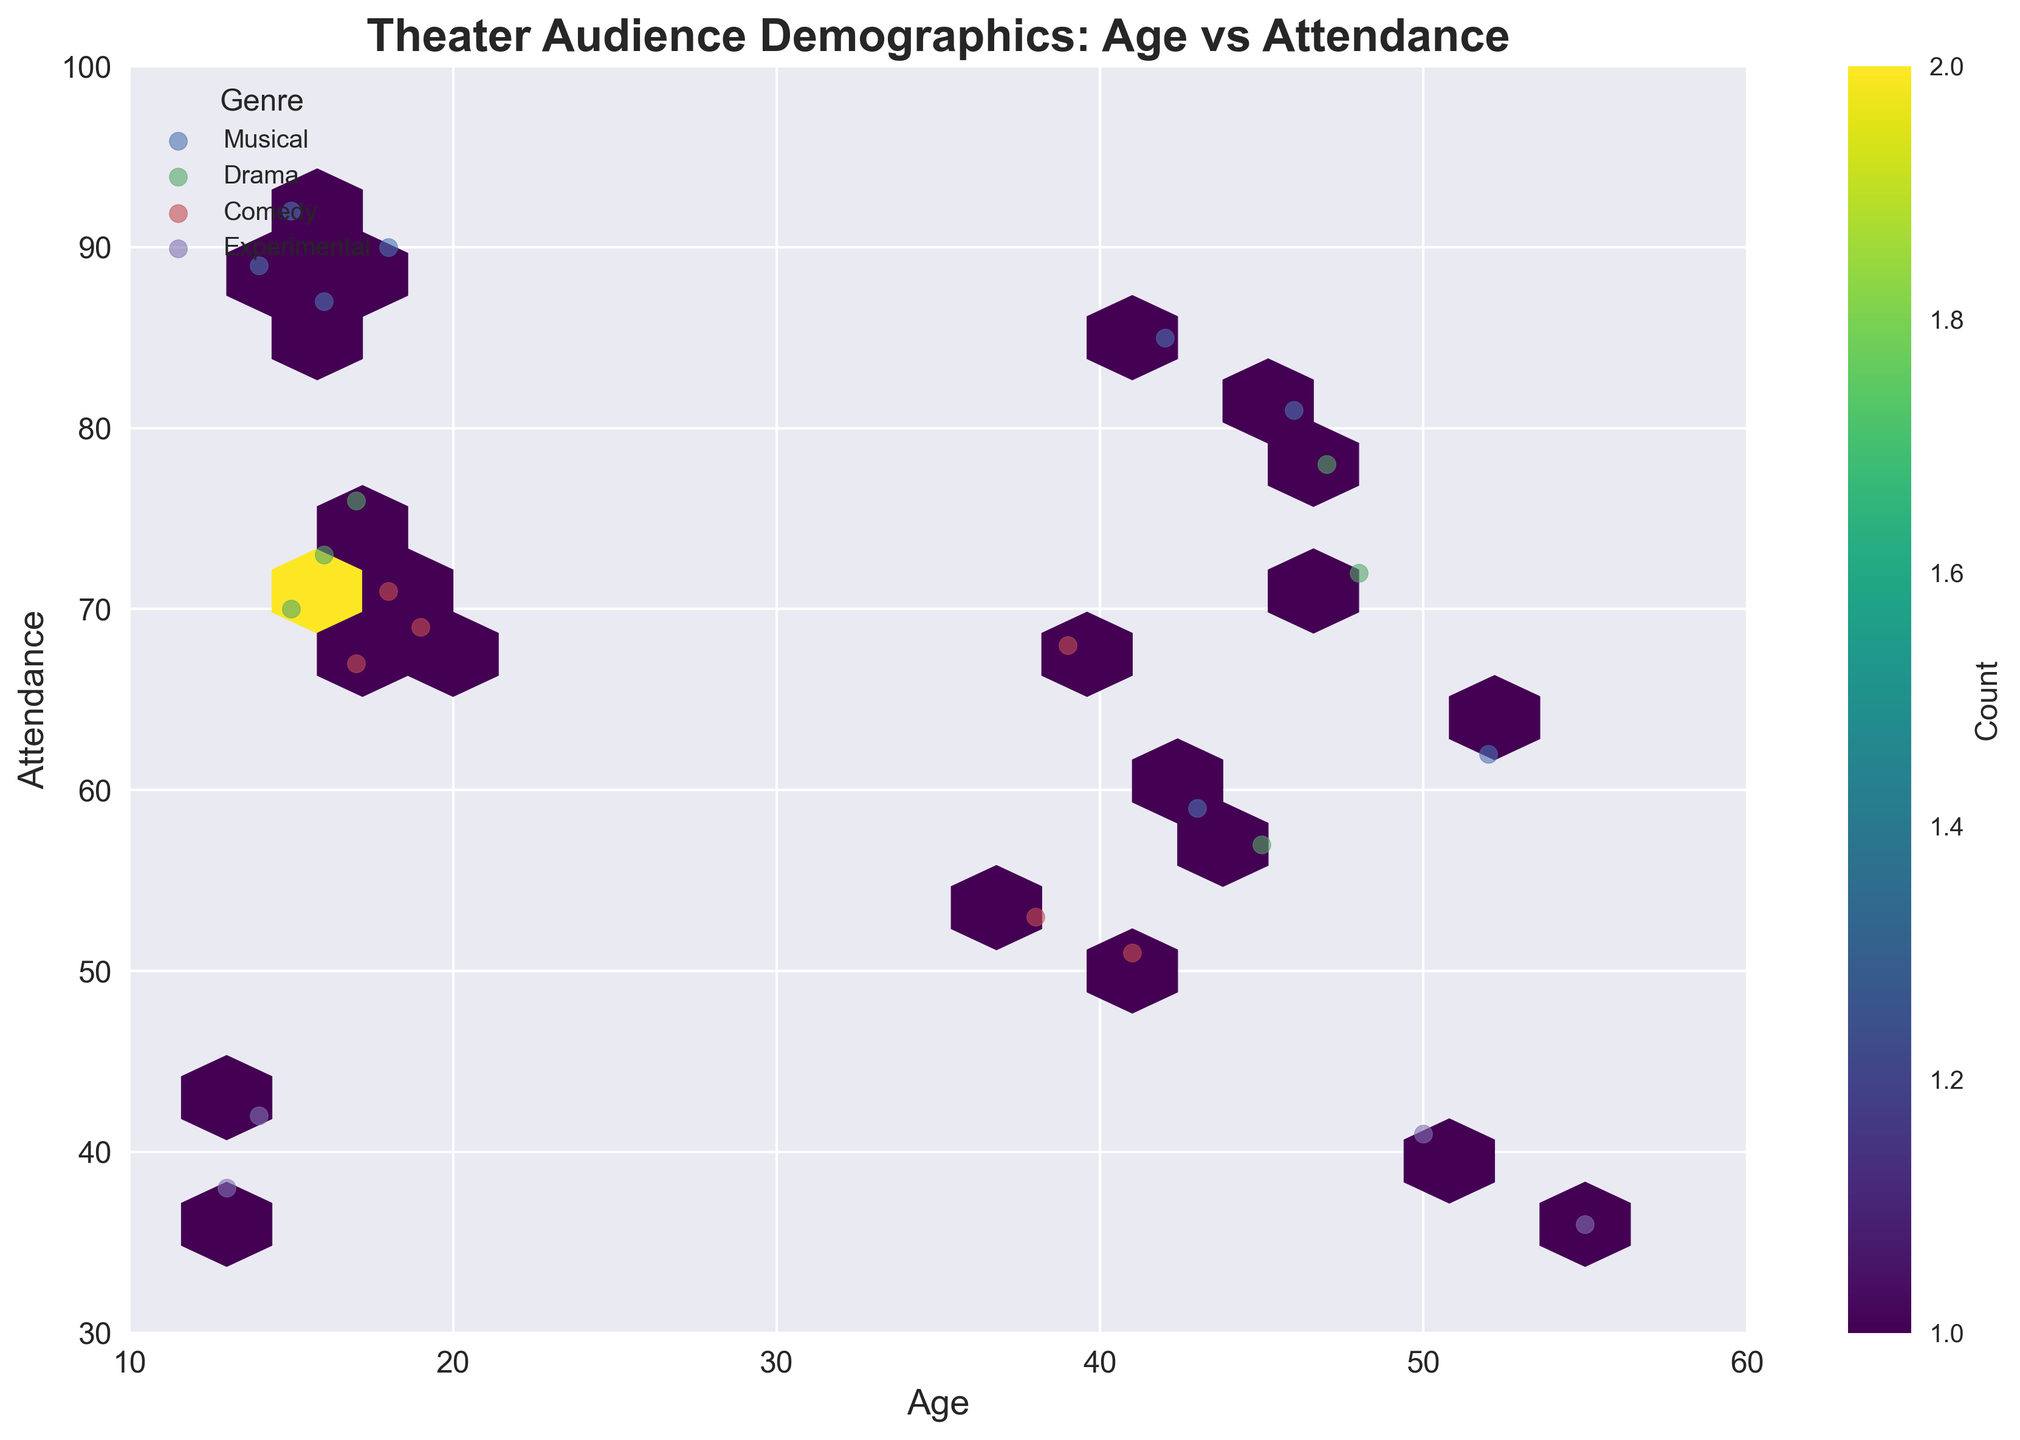What's the title of the figure? The title of the figure is usually found at the top of the chart and provides a brief description of what the figure is about. In this case, it is written clearly on top.
Answer: Theater Audience Demographics: Age vs Attendance What are the labels of the x-axis and y-axis? Axis labels provide information about what each axis represents. In the figure, these labels appear along the edges of the plot.
Answer: Age (x-axis), Attendance (y-axis) Which genre has the most scattered points above 80 attendance? To answer this, we look at the scatter points' vertical position and identify the genre associated with the points above the 80 attendance mark.
Answer: Musical What is the range of the age axis? We determine the range of the age axis by looking at the minimum and maximum values indicated along the x-axis of the plot.
Answer: 10 to 60 How does the attendance of comedy compare across different age groups? This involves checking the scatter points for comedy and observing how they are distributed across the age axis. We notice that comedy attendance points are fairly consistent and clustered around the mid-60s to low 70s across ages.
Answer: Consistent, around mid-60s to low 70s regardless of age Which genre has the least number of data points? By counting the scatter points corresponding to each genre, we find that certain genres have fewer points represented.
Answer: Experimental How many genres are displayed in the figure? The legend typically lists all the genres represented in the plot. Each entry in the legend corresponds to a different genre plotted in the chart.
Answer: 4 genres Which genre shows more variation in attendance for individuals aged 15 to 20? To determine this, we examine the scatter points for each genre within the specified age range. We observe the spread of points on the y-axis.
Answer: Musical What does the color bar represent, and how does it relate to the hexagonal bins? The color bar shows the count of points within each hexagonal bin. This represents the density of points in different areas of the plot. Darker colors indicate higher densities.
Answer: Density of data points Is there any genre that has high attendance uniformly across a wide age range? We look at each genre's scatter points and see if any genre shows consistently high attendance across different ages. The genre with scattered points in the upper region of the y-axis over a broad age range is identified.
Answer: Musical 